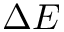Convert formula to latex. <formula><loc_0><loc_0><loc_500><loc_500>\Delta E</formula> 